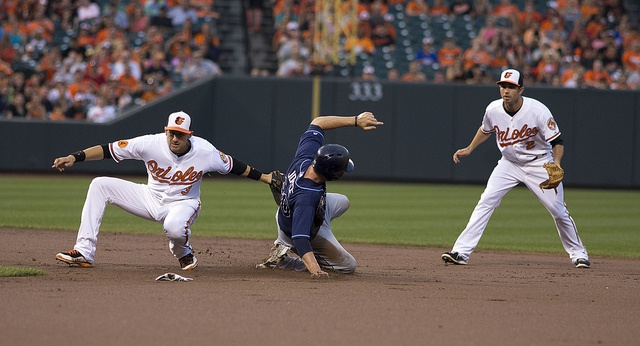Describe the objects in this image and their specific colors. I can see people in gray, lavender, black, and darkgray tones, people in gray, lavender, darkgray, and black tones, people in gray, black, navy, and darkgray tones, people in gray, black, brown, and maroon tones, and people in gray, maroon, brown, and black tones in this image. 